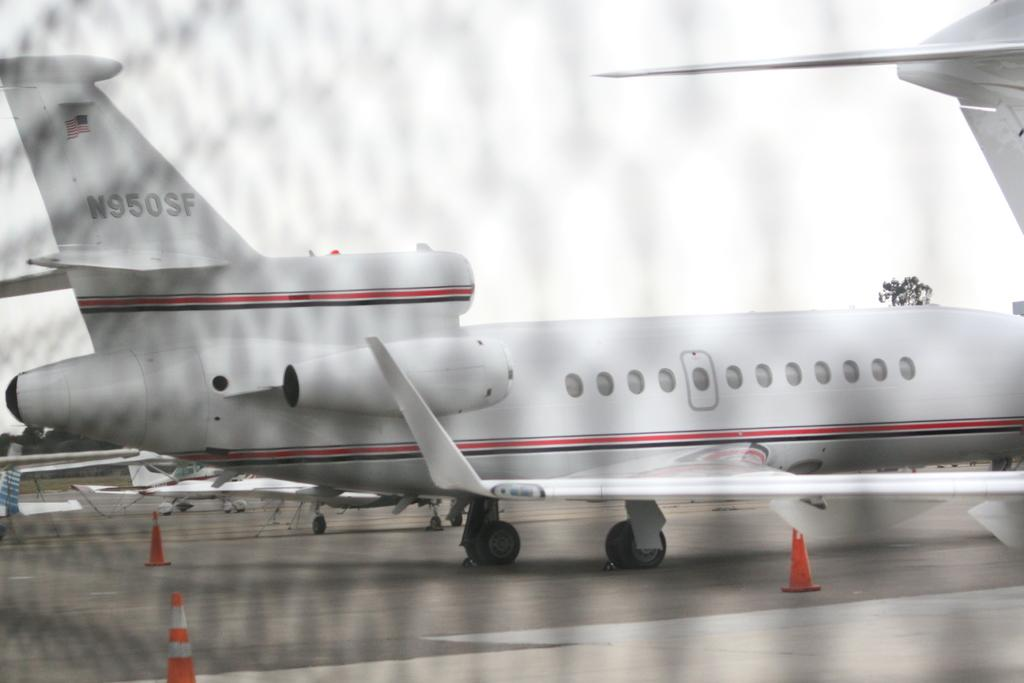What is the main subject of the image? The main subject of the image is airplanes on the ground. What can be seen in the sky in the image? The sky is visible at the top of the image. What type of natural scenery is present in the background of the image? There are trees in the background of the image. What type of acoustics can be heard in the image? There is no information about sounds or acoustics in the image, so it cannot be determined. 